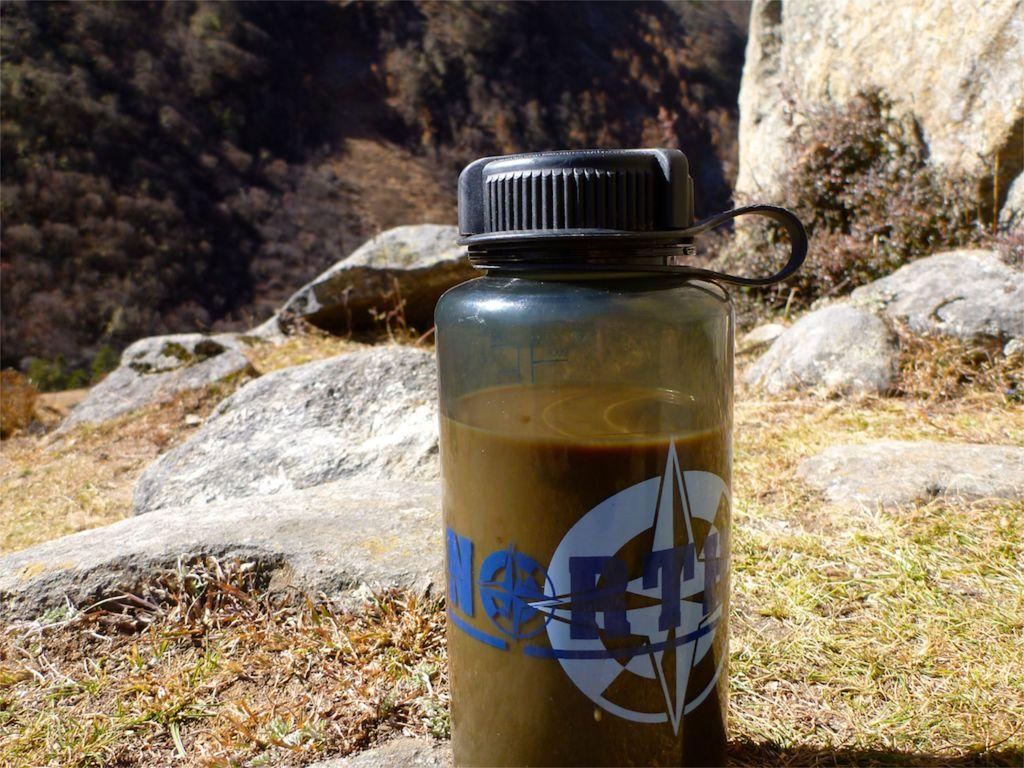What is placed on the floor in the image? There is a bottle placed on the floor. What can be seen in the background of the image? There are stones and trees visible in the background of the image. How many geese are biting the cork in the image? There are no geese or cork present in the image. 